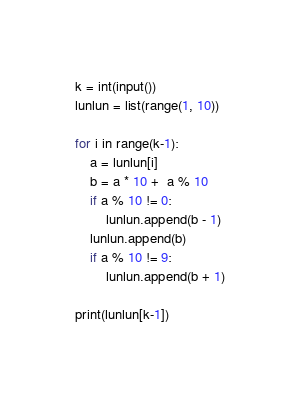<code> <loc_0><loc_0><loc_500><loc_500><_Python_>k = int(input())
lunlun = list(range(1, 10))

for i in range(k-1):
    a = lunlun[i]
    b = a * 10 +  a % 10 
    if a % 10 != 0:
        lunlun.append(b - 1)
    lunlun.append(b)
    if a % 10 != 9:
        lunlun.append(b + 1)

print(lunlun[k-1])</code> 